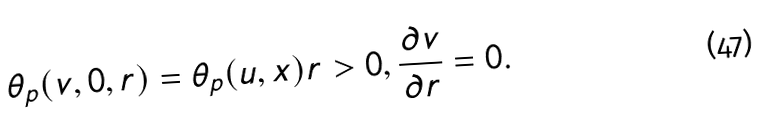<formula> <loc_0><loc_0><loc_500><loc_500>\theta _ { p } ( v , 0 , r ) = \theta _ { p } ( u , x ) r > 0 , \frac { \partial v } { \partial r } = 0 .</formula> 